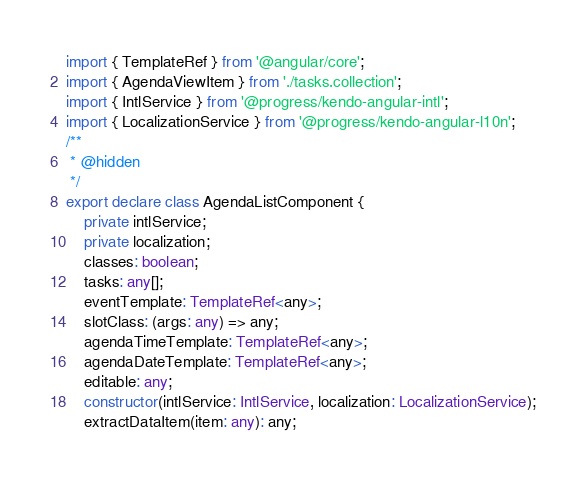Convert code to text. <code><loc_0><loc_0><loc_500><loc_500><_TypeScript_>import { TemplateRef } from '@angular/core';
import { AgendaViewItem } from './tasks.collection';
import { IntlService } from '@progress/kendo-angular-intl';
import { LocalizationService } from '@progress/kendo-angular-l10n';
/**
 * @hidden
 */
export declare class AgendaListComponent {
    private intlService;
    private localization;
    classes: boolean;
    tasks: any[];
    eventTemplate: TemplateRef<any>;
    slotClass: (args: any) => any;
    agendaTimeTemplate: TemplateRef<any>;
    agendaDateTemplate: TemplateRef<any>;
    editable: any;
    constructor(intlService: IntlService, localization: LocalizationService);
    extractDataItem(item: any): any;</code> 